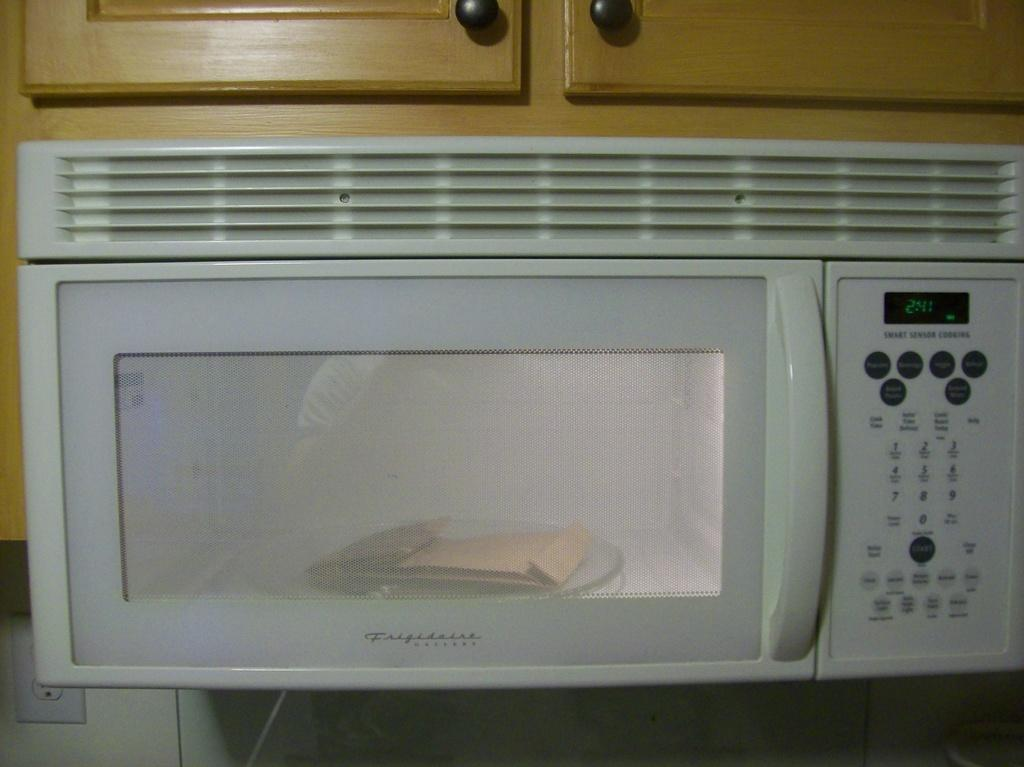What appliance is visible in the image? There is a microwave oven in the image. What color is the microwave oven? The microwave oven is white in color. What is located above the microwave oven in the image? There is a cupboard on top of the microwave oven. What type of muscle is being exercised by the microwave oven in the image? The microwave oven is an appliance and does not have muscles, so this question is not applicable to the image. 